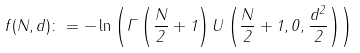Convert formula to latex. <formula><loc_0><loc_0><loc_500><loc_500>f ( N , d ) \colon = - \ln \left ( \Gamma \left ( \frac { N } { 2 } + 1 \right ) U \left ( \frac { N } { 2 } + 1 , 0 , \frac { d ^ { 2 } } { 2 } \right ) \right )</formula> 